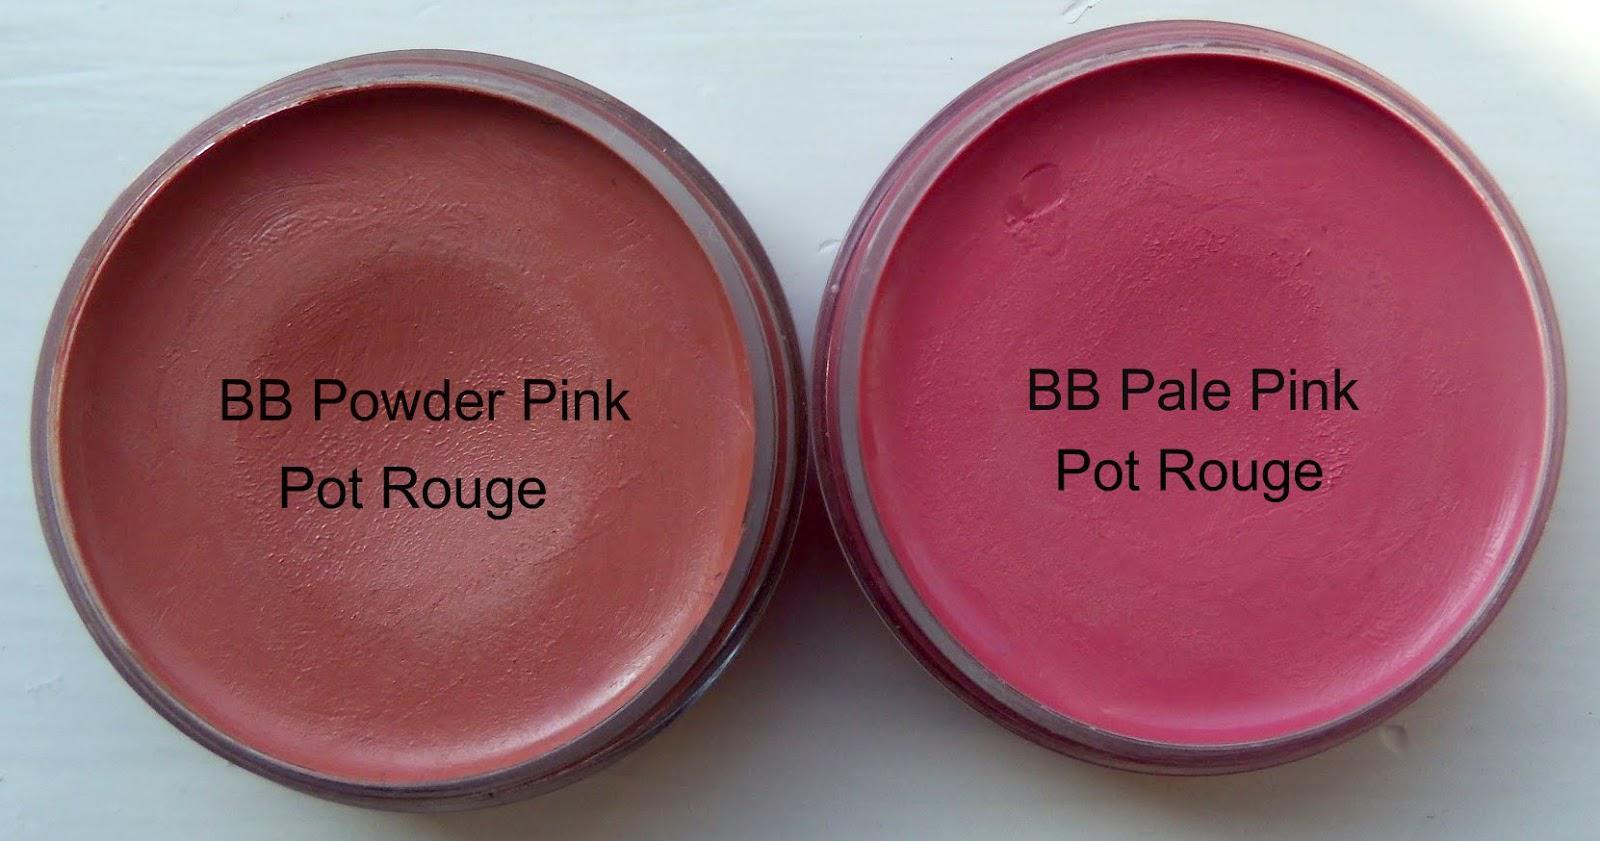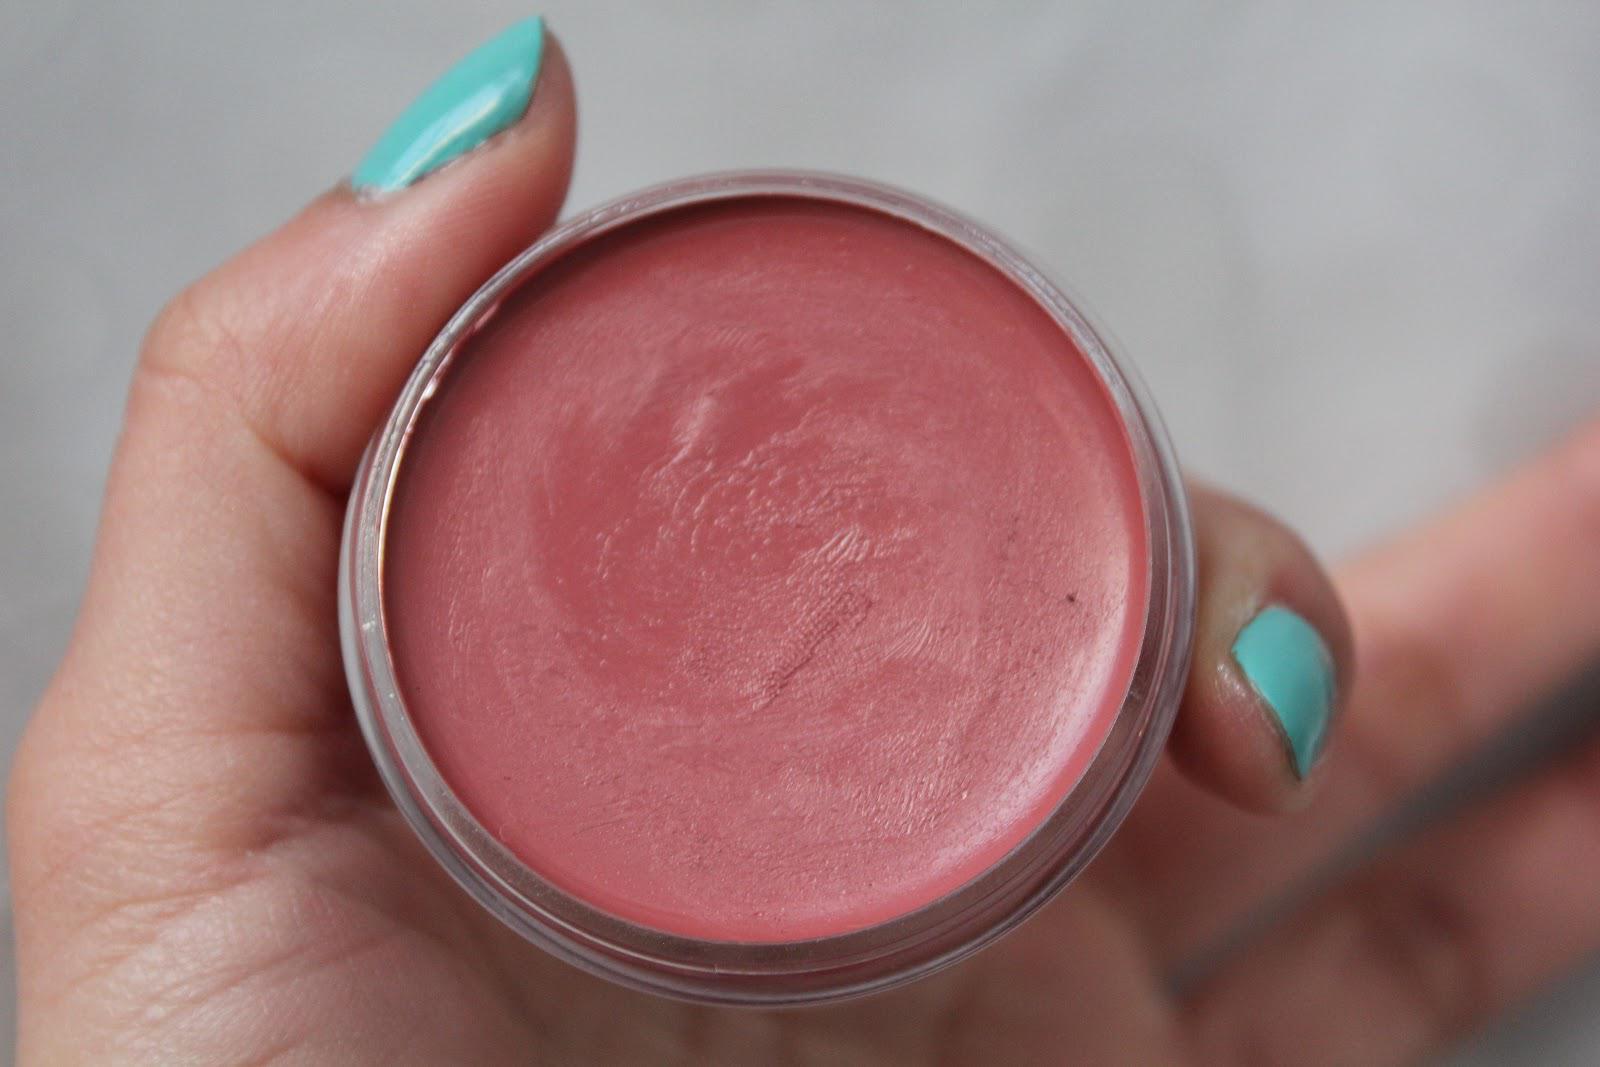The first image is the image on the left, the second image is the image on the right. Given the left and right images, does the statement "There is at most 1 hand holding reddish makeup." hold true? Answer yes or no. Yes. The first image is the image on the left, the second image is the image on the right. Given the left and right images, does the statement "One of the images in the pair shows a hand holding the makeup." hold true? Answer yes or no. Yes. 